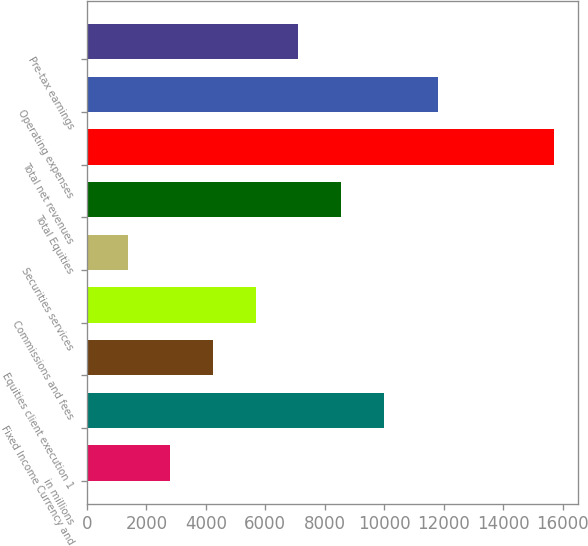Convert chart to OTSL. <chart><loc_0><loc_0><loc_500><loc_500><bar_chart><fcel>in millions<fcel>Fixed Income Currency and<fcel>Equities client execution 1<fcel>Commissions and fees<fcel>Securities services<fcel>Total Equities<fcel>Total net revenues<fcel>Operating expenses<fcel>Pre-tax earnings<nl><fcel>2807.8<fcel>9981.8<fcel>4242.6<fcel>5677.4<fcel>1373<fcel>8547<fcel>15721<fcel>11792<fcel>7112.2<nl></chart> 